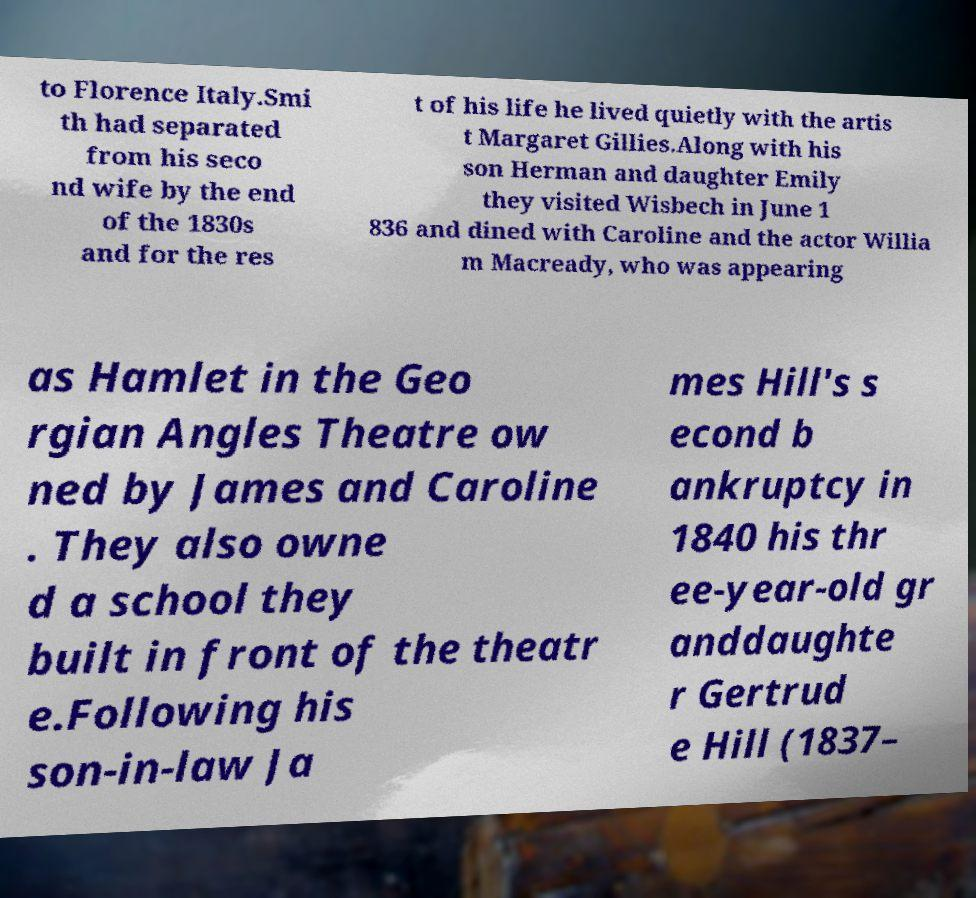I need the written content from this picture converted into text. Can you do that? to Florence Italy.Smi th had separated from his seco nd wife by the end of the 1830s and for the res t of his life he lived quietly with the artis t Margaret Gillies.Along with his son Herman and daughter Emily they visited Wisbech in June 1 836 and dined with Caroline and the actor Willia m Macready, who was appearing as Hamlet in the Geo rgian Angles Theatre ow ned by James and Caroline . They also owne d a school they built in front of the theatr e.Following his son-in-law Ja mes Hill's s econd b ankruptcy in 1840 his thr ee-year-old gr anddaughte r Gertrud e Hill (1837– 